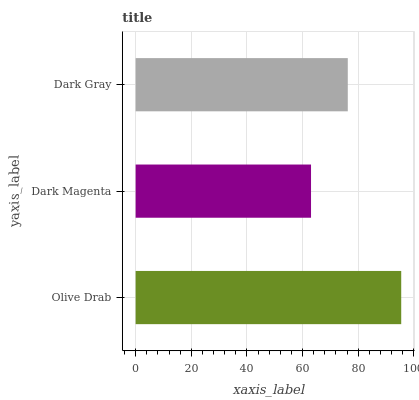Is Dark Magenta the minimum?
Answer yes or no. Yes. Is Olive Drab the maximum?
Answer yes or no. Yes. Is Dark Gray the minimum?
Answer yes or no. No. Is Dark Gray the maximum?
Answer yes or no. No. Is Dark Gray greater than Dark Magenta?
Answer yes or no. Yes. Is Dark Magenta less than Dark Gray?
Answer yes or no. Yes. Is Dark Magenta greater than Dark Gray?
Answer yes or no. No. Is Dark Gray less than Dark Magenta?
Answer yes or no. No. Is Dark Gray the high median?
Answer yes or no. Yes. Is Dark Gray the low median?
Answer yes or no. Yes. Is Olive Drab the high median?
Answer yes or no. No. Is Olive Drab the low median?
Answer yes or no. No. 